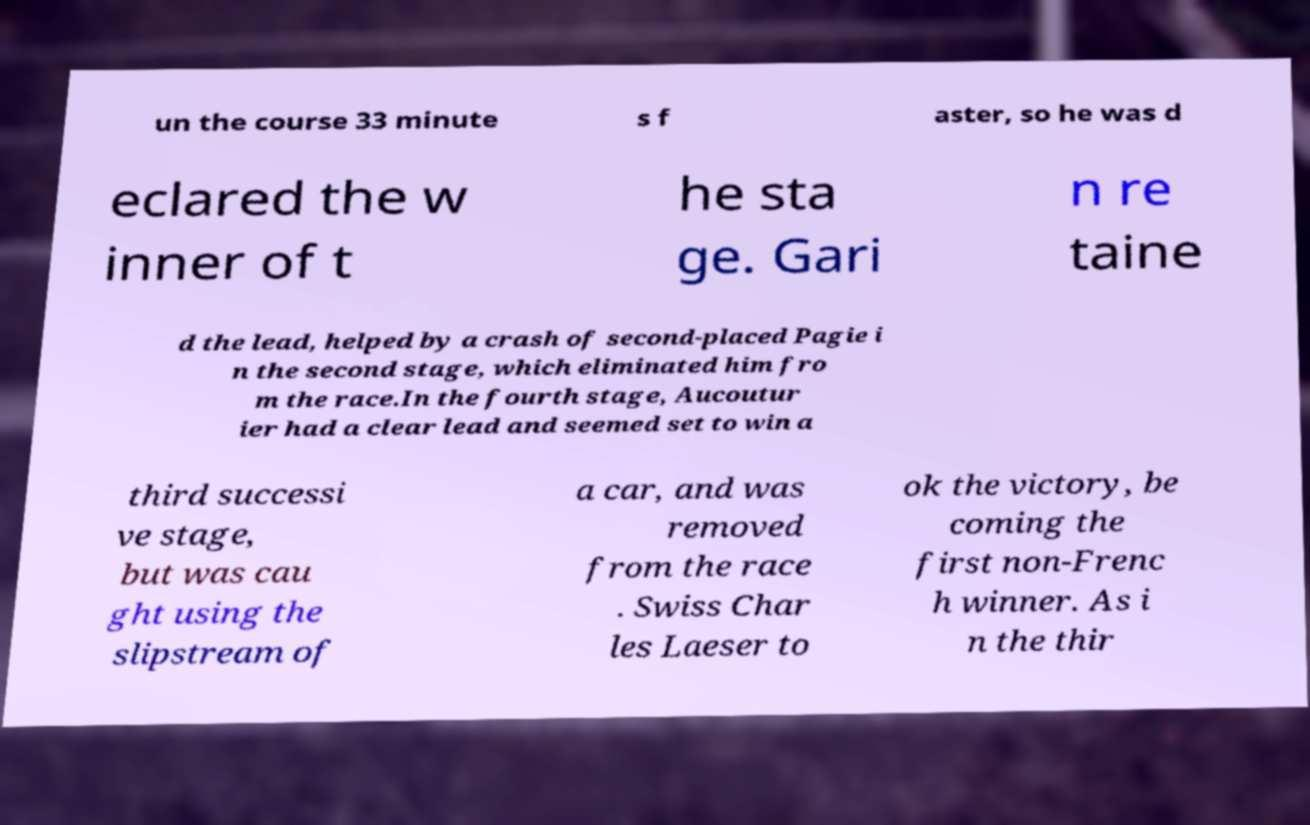I need the written content from this picture converted into text. Can you do that? un the course 33 minute s f aster, so he was d eclared the w inner of t he sta ge. Gari n re taine d the lead, helped by a crash of second-placed Pagie i n the second stage, which eliminated him fro m the race.In the fourth stage, Aucoutur ier had a clear lead and seemed set to win a third successi ve stage, but was cau ght using the slipstream of a car, and was removed from the race . Swiss Char les Laeser to ok the victory, be coming the first non-Frenc h winner. As i n the thir 